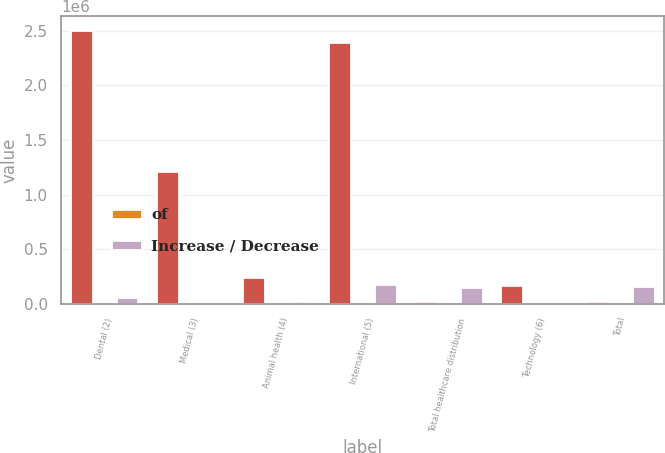Convert chart to OTSL. <chart><loc_0><loc_0><loc_500><loc_500><stacked_bar_chart><ecel><fcel>Dental (2)<fcel>Medical (3)<fcel>Animal health (4)<fcel>International (5)<fcel>Total healthcare distribution<fcel>Technology (6)<fcel>Total<nl><fcel>nan<fcel>2.50992e+06<fcel>1.21702e+06<fcel>240082<fcel>2.3981e+06<fcel>21989<fcel>173208<fcel>21989<nl><fcel>of<fcel>38.4<fcel>18.6<fcel>3.7<fcel>36.7<fcel>97.4<fcel>2.6<fcel>100<nl><fcel>Increase / Decrease<fcel>57143<fcel>6145<fcel>21989<fcel>177013<fcel>148004<fcel>9919<fcel>157923<nl></chart> 